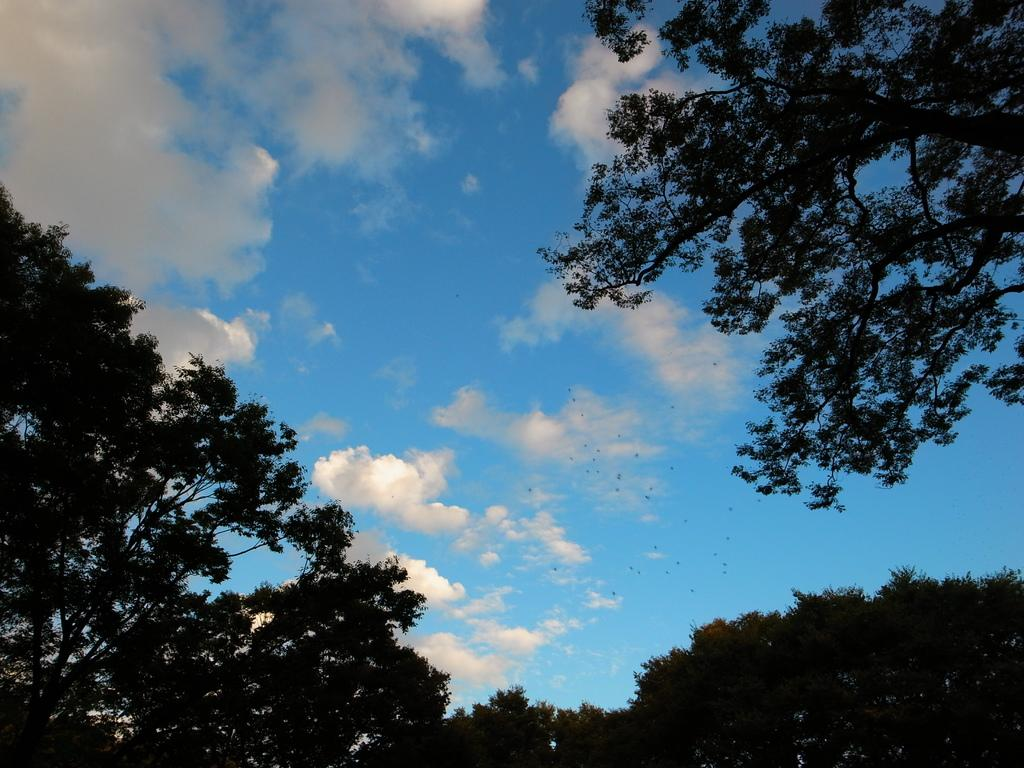What type of vegetation can be seen in the image? There are trees in the image. What part of the natural environment is visible in the image? The sky is visible in the background of the image. What type of reward can be seen hanging from the trees in the image? There is no reward visible in the image; it only features trees and the sky. 